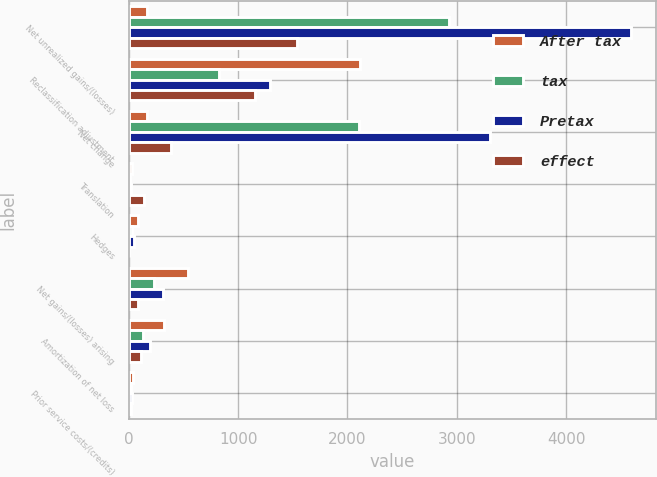Convert chart to OTSL. <chart><loc_0><loc_0><loc_500><loc_500><stacked_bar_chart><ecel><fcel>Net unrealized gains/(losses)<fcel>Reclassification adjustment<fcel>Net change<fcel>Translation<fcel>Hedges<fcel>Net gains/(losses) arising<fcel>Amortization of net loss<fcel>Prior service costs/(credits)<nl><fcel>After tax<fcel>168.5<fcel>2110<fcel>168.5<fcel>26<fcel>82<fcel>537<fcel>324<fcel>41<nl><fcel>tax<fcel>2930<fcel>822<fcel>2108<fcel>8<fcel>31<fcel>228<fcel>126<fcel>16<nl><fcel>Pretax<fcel>4591<fcel>1288<fcel>3303<fcel>18<fcel>51<fcel>309<fcel>198<fcel>25<nl><fcel>effect<fcel>1540<fcel>1150<fcel>390<fcel>139<fcel>5<fcel>84<fcel>112<fcel>22<nl></chart> 